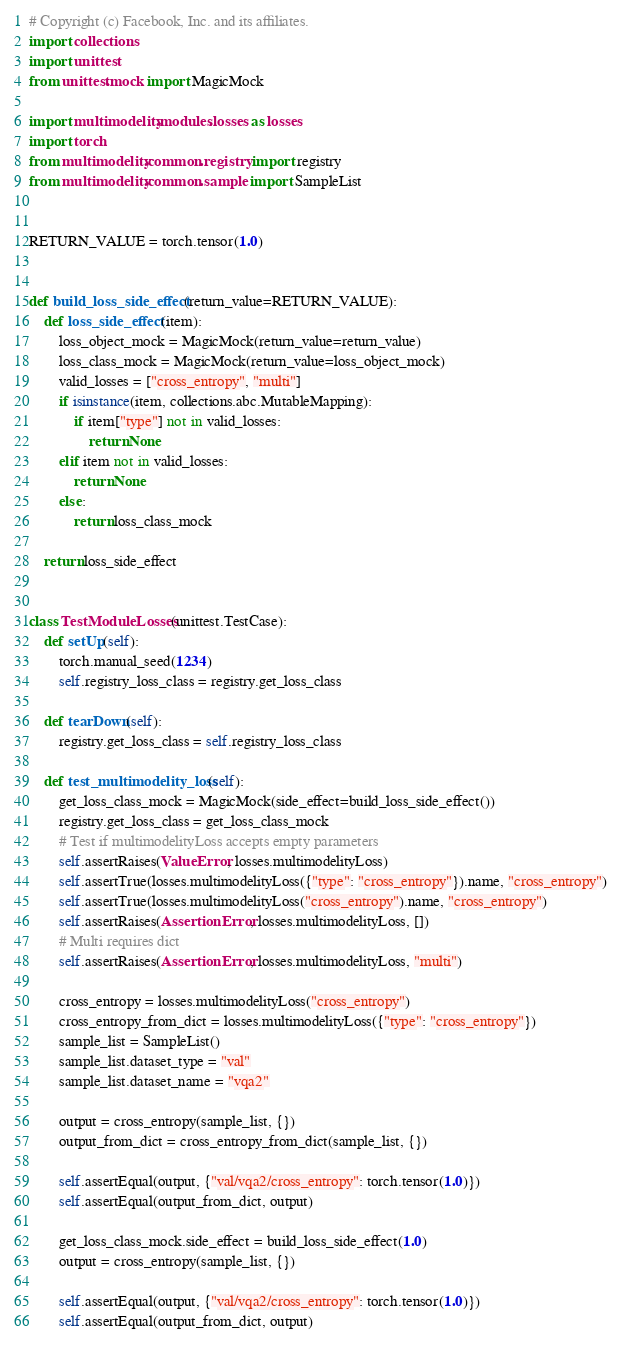Convert code to text. <code><loc_0><loc_0><loc_500><loc_500><_Python_># Copyright (c) Facebook, Inc. and its affiliates.
import collections
import unittest
from unittest.mock import MagicMock

import multimodelity.modules.losses as losses
import torch
from multimodelity.common.registry import registry
from multimodelity.common.sample import SampleList


RETURN_VALUE = torch.tensor(1.0)


def build_loss_side_effect(return_value=RETURN_VALUE):
    def loss_side_effect(item):
        loss_object_mock = MagicMock(return_value=return_value)
        loss_class_mock = MagicMock(return_value=loss_object_mock)
        valid_losses = ["cross_entropy", "multi"]
        if isinstance(item, collections.abc.MutableMapping):
            if item["type"] not in valid_losses:
                return None
        elif item not in valid_losses:
            return None
        else:
            return loss_class_mock

    return loss_side_effect


class TestModuleLosses(unittest.TestCase):
    def setUp(self):
        torch.manual_seed(1234)
        self.registry_loss_class = registry.get_loss_class

    def tearDown(self):
        registry.get_loss_class = self.registry_loss_class

    def test_multimodelity_loss(self):
        get_loss_class_mock = MagicMock(side_effect=build_loss_side_effect())
        registry.get_loss_class = get_loss_class_mock
        # Test if multimodelityLoss accepts empty parameters
        self.assertRaises(ValueError, losses.multimodelityLoss)
        self.assertTrue(losses.multimodelityLoss({"type": "cross_entropy"}).name, "cross_entropy")
        self.assertTrue(losses.multimodelityLoss("cross_entropy").name, "cross_entropy")
        self.assertRaises(AssertionError, losses.multimodelityLoss, [])
        # Multi requires dict
        self.assertRaises(AssertionError, losses.multimodelityLoss, "multi")

        cross_entropy = losses.multimodelityLoss("cross_entropy")
        cross_entropy_from_dict = losses.multimodelityLoss({"type": "cross_entropy"})
        sample_list = SampleList()
        sample_list.dataset_type = "val"
        sample_list.dataset_name = "vqa2"

        output = cross_entropy(sample_list, {})
        output_from_dict = cross_entropy_from_dict(sample_list, {})

        self.assertEqual(output, {"val/vqa2/cross_entropy": torch.tensor(1.0)})
        self.assertEqual(output_from_dict, output)

        get_loss_class_mock.side_effect = build_loss_side_effect(1.0)
        output = cross_entropy(sample_list, {})

        self.assertEqual(output, {"val/vqa2/cross_entropy": torch.tensor(1.0)})
        self.assertEqual(output_from_dict, output)
</code> 